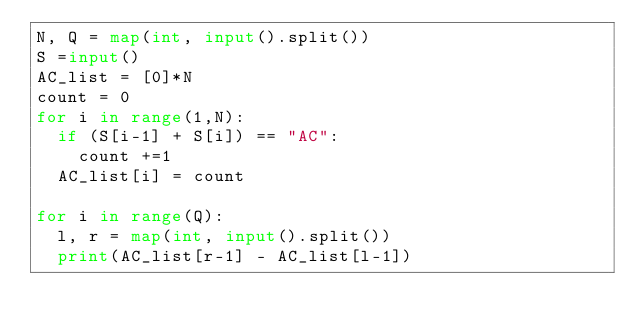Convert code to text. <code><loc_0><loc_0><loc_500><loc_500><_Python_>N, Q = map(int, input().split())
S =input()
AC_list = [0]*N
count = 0
for i in range(1,N):
  if (S[i-1] + S[i]) == "AC":
    count +=1
  AC_list[i] = count

for i in range(Q):
  l, r = map(int, input().split())
  print(AC_list[r-1] - AC_list[l-1])

  
  </code> 